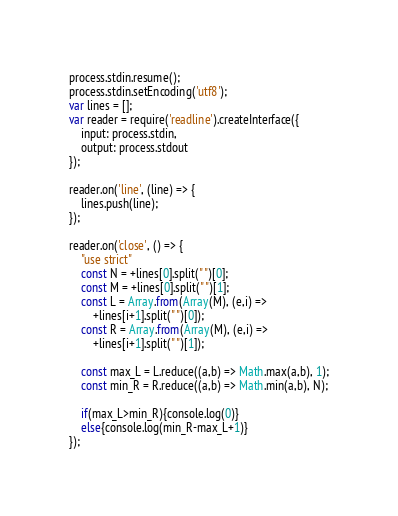<code> <loc_0><loc_0><loc_500><loc_500><_JavaScript_>process.stdin.resume();
process.stdin.setEncoding('utf8'); 
var lines = [];
var reader = require('readline').createInterface({
	input: process.stdin,
	output: process.stdout
});
 
reader.on('line', (line) => {
	lines.push(line);
});

reader.on('close', () => {
	"use strict"
	const N = +lines[0].split(" ")[0];
	const M = +lines[0].split(" ")[1];
	const L = Array.from(Array(M), (e,i) => 
		+lines[i+1].split(" ")[0]);
	const R = Array.from(Array(M), (e,i) => 
		+lines[i+1].split(" ")[1]);
	
	const max_L = L.reduce((a,b) => Math.max(a,b), 1);
	const min_R = R.reduce((a,b) => Math.min(a,b), N);
	
	if(max_L>min_R){console.log(0)}
	else{console.log(min_R-max_L+1)}
});</code> 